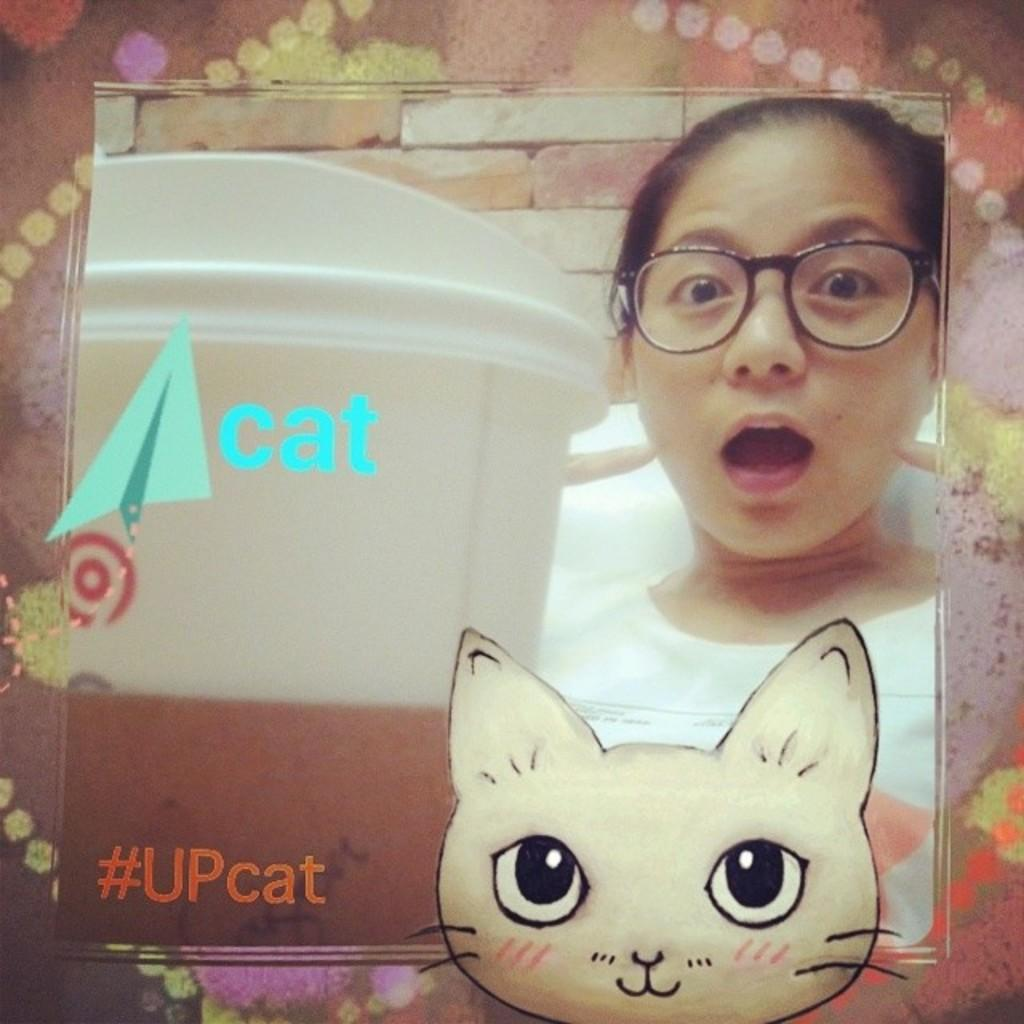Who is present in the image? There is a girl in the image. What else can be seen in the image besides the girl? There is text and an image of a cartoon in the image. What hobbies does the girl have, as depicted in the image? The image does not provide information about the girl's hobbies. 